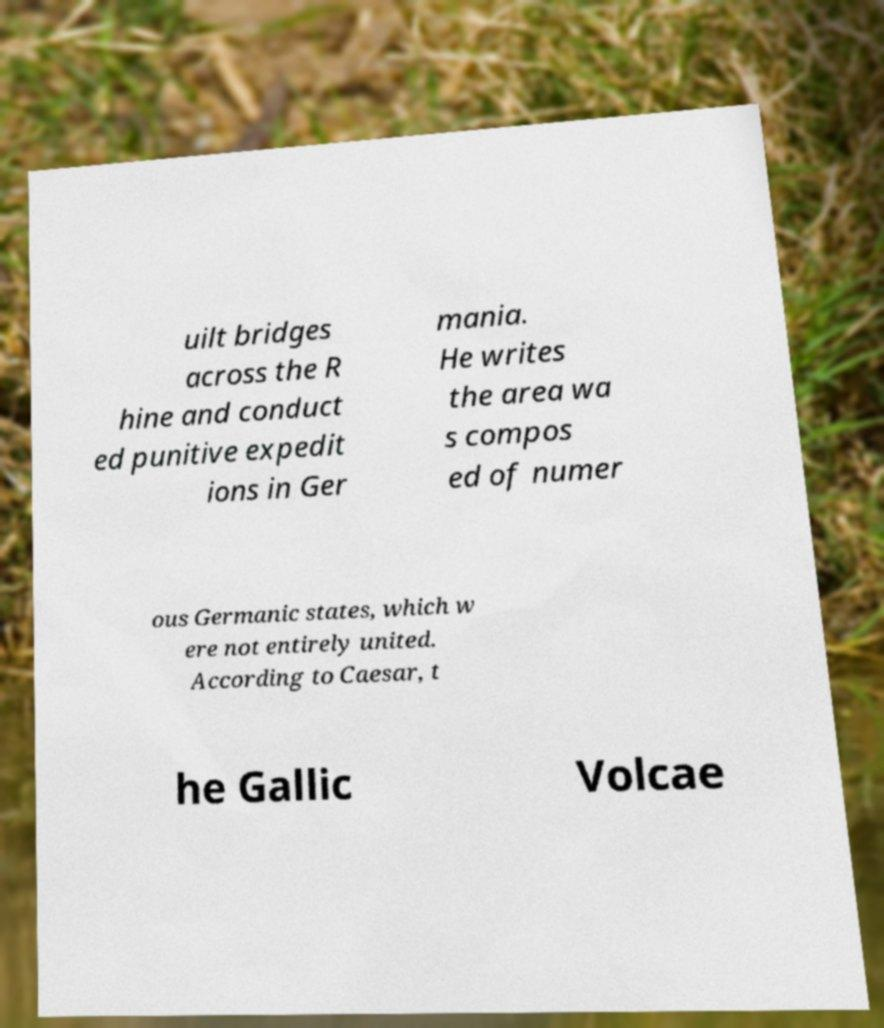For documentation purposes, I need the text within this image transcribed. Could you provide that? uilt bridges across the R hine and conduct ed punitive expedit ions in Ger mania. He writes the area wa s compos ed of numer ous Germanic states, which w ere not entirely united. According to Caesar, t he Gallic Volcae 